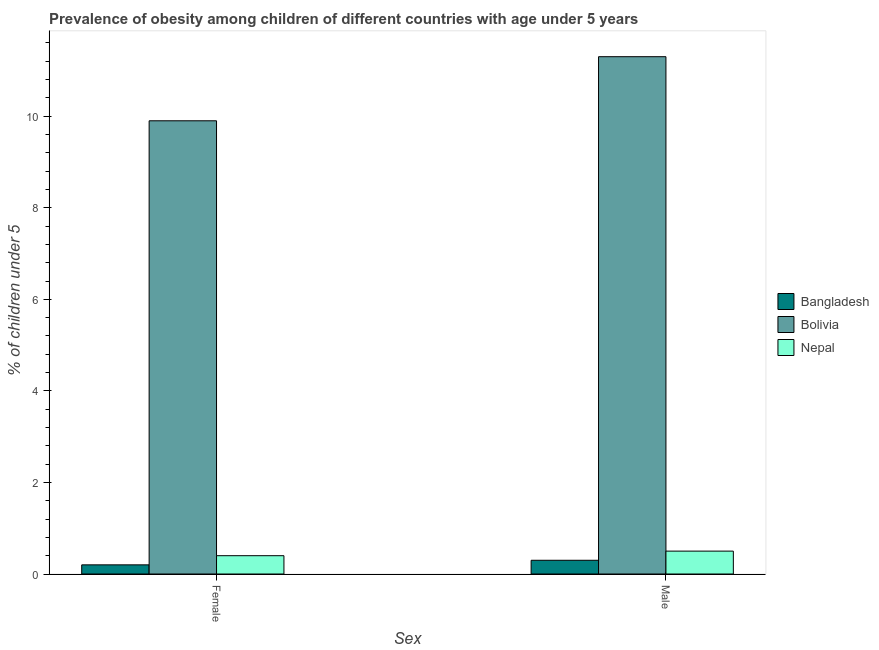How many different coloured bars are there?
Offer a terse response. 3. How many groups of bars are there?
Offer a terse response. 2. How many bars are there on the 1st tick from the right?
Offer a terse response. 3. What is the percentage of obese female children in Bolivia?
Keep it short and to the point. 9.9. Across all countries, what is the maximum percentage of obese male children?
Keep it short and to the point. 11.3. Across all countries, what is the minimum percentage of obese female children?
Provide a succinct answer. 0.2. In which country was the percentage of obese male children minimum?
Provide a short and direct response. Bangladesh. What is the total percentage of obese male children in the graph?
Your response must be concise. 12.1. What is the difference between the percentage of obese female children in Bolivia and that in Bangladesh?
Make the answer very short. 9.7. What is the difference between the percentage of obese male children in Nepal and the percentage of obese female children in Bolivia?
Your answer should be very brief. -9.4. What is the average percentage of obese female children per country?
Give a very brief answer. 3.5. What is the difference between the percentage of obese female children and percentage of obese male children in Bangladesh?
Your response must be concise. -0.1. In how many countries, is the percentage of obese female children greater than 8.4 %?
Provide a succinct answer. 1. What is the ratio of the percentage of obese male children in Bangladesh to that in Nepal?
Give a very brief answer. 0.6. What does the 2nd bar from the left in Male represents?
Your response must be concise. Bolivia. How many bars are there?
Make the answer very short. 6. What is the difference between two consecutive major ticks on the Y-axis?
Provide a succinct answer. 2. Does the graph contain any zero values?
Provide a succinct answer. No. Does the graph contain grids?
Offer a very short reply. No. Where does the legend appear in the graph?
Offer a terse response. Center right. What is the title of the graph?
Give a very brief answer. Prevalence of obesity among children of different countries with age under 5 years. Does "Argentina" appear as one of the legend labels in the graph?
Keep it short and to the point. No. What is the label or title of the X-axis?
Keep it short and to the point. Sex. What is the label or title of the Y-axis?
Give a very brief answer.  % of children under 5. What is the  % of children under 5 of Bangladesh in Female?
Provide a succinct answer. 0.2. What is the  % of children under 5 of Bolivia in Female?
Offer a terse response. 9.9. What is the  % of children under 5 of Nepal in Female?
Keep it short and to the point. 0.4. What is the  % of children under 5 in Bangladesh in Male?
Provide a succinct answer. 0.3. What is the  % of children under 5 of Bolivia in Male?
Ensure brevity in your answer.  11.3. What is the  % of children under 5 of Nepal in Male?
Give a very brief answer. 0.5. Across all Sex, what is the maximum  % of children under 5 in Bangladesh?
Offer a terse response. 0.3. Across all Sex, what is the maximum  % of children under 5 in Bolivia?
Give a very brief answer. 11.3. Across all Sex, what is the maximum  % of children under 5 in Nepal?
Provide a succinct answer. 0.5. Across all Sex, what is the minimum  % of children under 5 in Bangladesh?
Your answer should be compact. 0.2. Across all Sex, what is the minimum  % of children under 5 in Bolivia?
Provide a succinct answer. 9.9. Across all Sex, what is the minimum  % of children under 5 of Nepal?
Your response must be concise. 0.4. What is the total  % of children under 5 in Bolivia in the graph?
Give a very brief answer. 21.2. What is the total  % of children under 5 in Nepal in the graph?
Make the answer very short. 0.9. What is the difference between the  % of children under 5 in Bangladesh in Female and that in Male?
Offer a very short reply. -0.1. What is the difference between the  % of children under 5 of Bolivia in Female and that in Male?
Offer a terse response. -1.4. What is the difference between the  % of children under 5 of Bangladesh in Female and the  % of children under 5 of Nepal in Male?
Your answer should be compact. -0.3. What is the difference between the  % of children under 5 in Bolivia in Female and the  % of children under 5 in Nepal in Male?
Make the answer very short. 9.4. What is the average  % of children under 5 of Nepal per Sex?
Offer a very short reply. 0.45. What is the difference between the  % of children under 5 in Bangladesh and  % of children under 5 in Bolivia in Female?
Ensure brevity in your answer.  -9.7. What is the difference between the  % of children under 5 in Bangladesh and  % of children under 5 in Nepal in Female?
Offer a very short reply. -0.2. What is the difference between the  % of children under 5 of Bangladesh and  % of children under 5 of Bolivia in Male?
Give a very brief answer. -11. What is the difference between the  % of children under 5 in Bangladesh and  % of children under 5 in Nepal in Male?
Your answer should be compact. -0.2. What is the difference between the  % of children under 5 in Bolivia and  % of children under 5 in Nepal in Male?
Provide a succinct answer. 10.8. What is the ratio of the  % of children under 5 of Bolivia in Female to that in Male?
Offer a very short reply. 0.88. What is the ratio of the  % of children under 5 in Nepal in Female to that in Male?
Provide a short and direct response. 0.8. What is the difference between the highest and the second highest  % of children under 5 of Bolivia?
Your answer should be very brief. 1.4. What is the difference between the highest and the lowest  % of children under 5 in Bangladesh?
Keep it short and to the point. 0.1. 